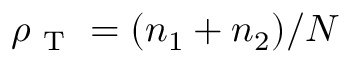<formula> <loc_0><loc_0><loc_500><loc_500>\rho _ { T } = ( n _ { 1 } + n _ { 2 } ) / N</formula> 